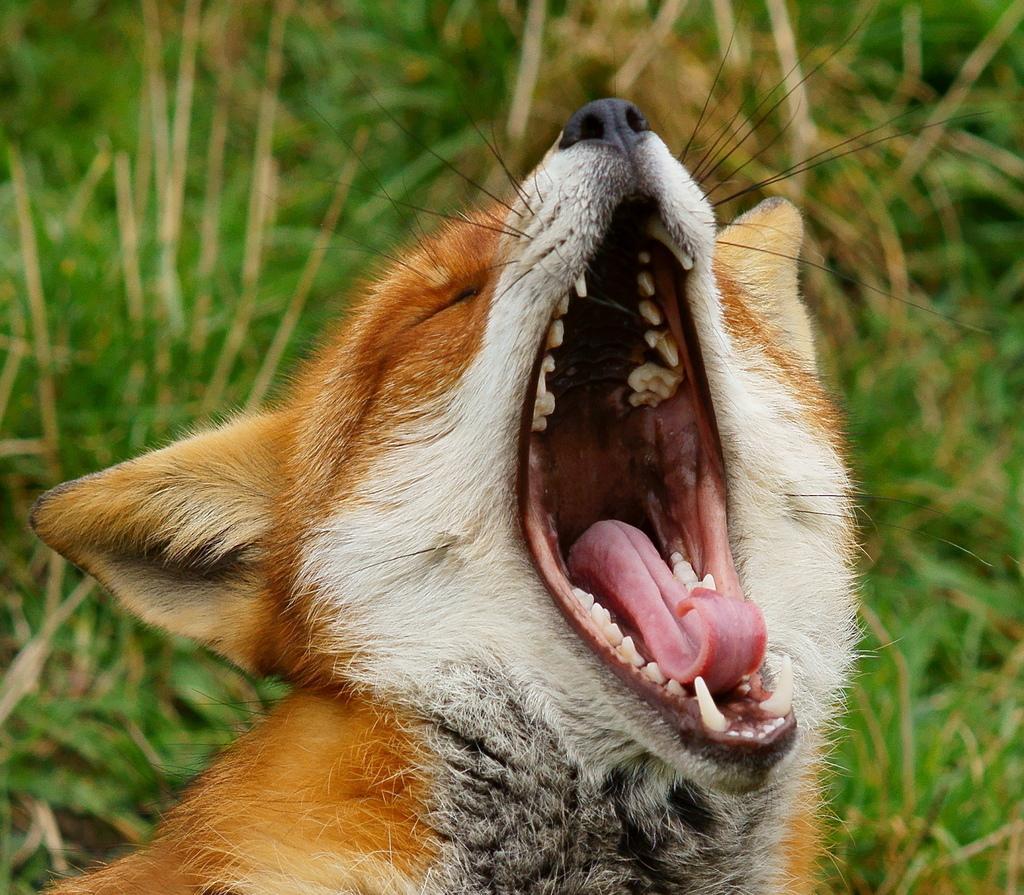How would you summarize this image in a sentence or two? In this image, we can see an animal open his mouth. Background there is a blur view. Here we can see plants. 